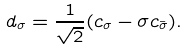<formula> <loc_0><loc_0><loc_500><loc_500>d _ { \sigma } = \frac { 1 } { \sqrt { 2 } } ( c _ { \sigma } - \sigma c _ { \bar { \sigma } } ) .</formula> 